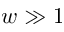<formula> <loc_0><loc_0><loc_500><loc_500>w \gg 1</formula> 